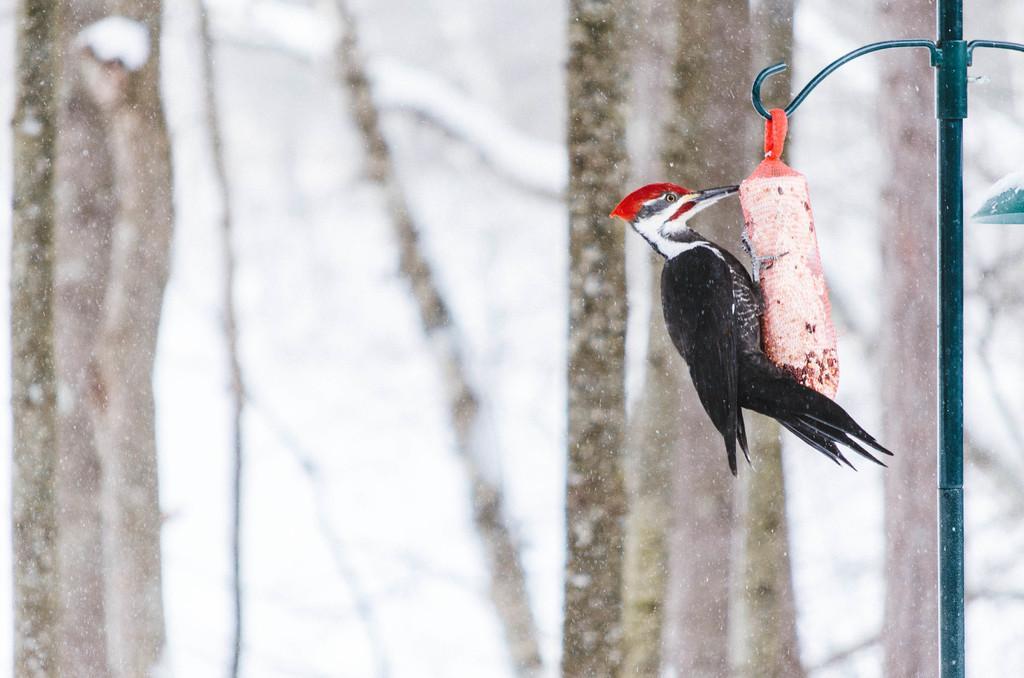How would you summarize this image in a sentence or two? In this image on the right side there is one board on some object, and there is a pole. And in the background there are some trees and snow. 